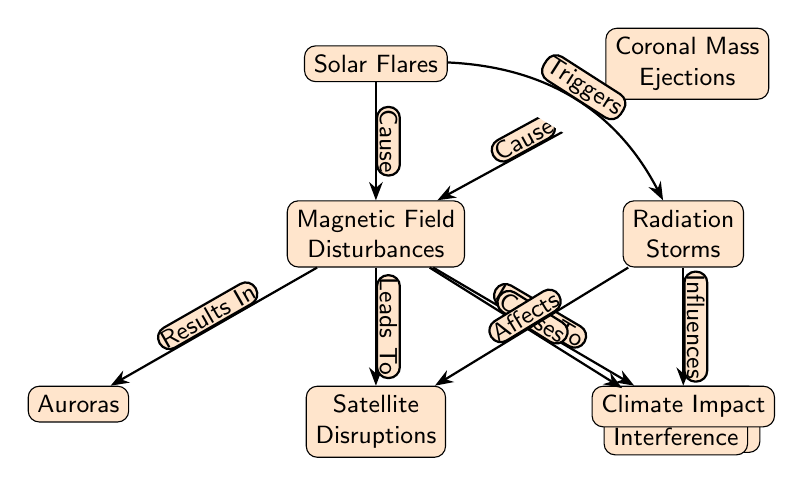What are the two primary causes illustrated in the diagram? The diagram shows "Solar Flares" and "Coronal Mass Ejections" at the top. These two nodes are the causes that lead to disturbances in the magnetic field.
Answer: Solar Flares, Coronal Mass Ejections Which phenomenon results in auroras? According to the flow of the diagram, "Magnetic Field Disturbances" leads to the formation of "Auroras," indicating that auroras are a result of these disturbances.
Answer: Auroras How many total effects are described in the diagram? There are five effects illustrated as nodes stemming from "Magnetic Field Disturbances" and "Radiation Storms." They include Auroras, Satellite Disruptions, Power Grid Failures, GPS Interference, and Climate Impact. Counting these gives a total of five effects.
Answer: Five What directly influences climate according to the diagram? The diagram shows that "Radiation Storms" influence "Climate Impact." This relationship highlights the influence of radiation storms on climate.
Answer: Radiation Storms What is the relationship between solar flares and radiation storms? The diagram indicates that solar flares "Trigger" radiation storms, establishing a cause-and-effect relationship between these two phenomena.
Answer: Triggers Which node has the most outgoing edges? The "Magnetic Field Disturbances" node has four outgoing edges leading to Auroras, Satellite Disruptions, Power Grid Failures, and GPS Interference. Thus, it has the most outgoing edges in the diagram.
Answer: Magnetic Field Disturbances Which nodes are directly impacted by "Radiation Storms"? According to the diagram, "Radiation Storms" affects "Satellite Disruptions" and "Climate Impact." Both nodes are directly influenced by radiation storms, highlighting their dependence on this phenomenon.
Answer: Satellite Disruptions, Climate Impact What leads to GPS interference? "Magnetic Field Disturbances" directly causes "GPS Interference" as indicated by a directional edge leading from magnetic disturbances to GPS interference in the diagram.
Answer: Magnetic Field Disturbances What are the consequences of solar flares as depicted in the diagram? The primary consequence shown in the diagram for solar flares is the "Radiation Storms," suggesting that solar flares can lead to the occurrence of radiation storms on Earth.
Answer: Radiation Storms 